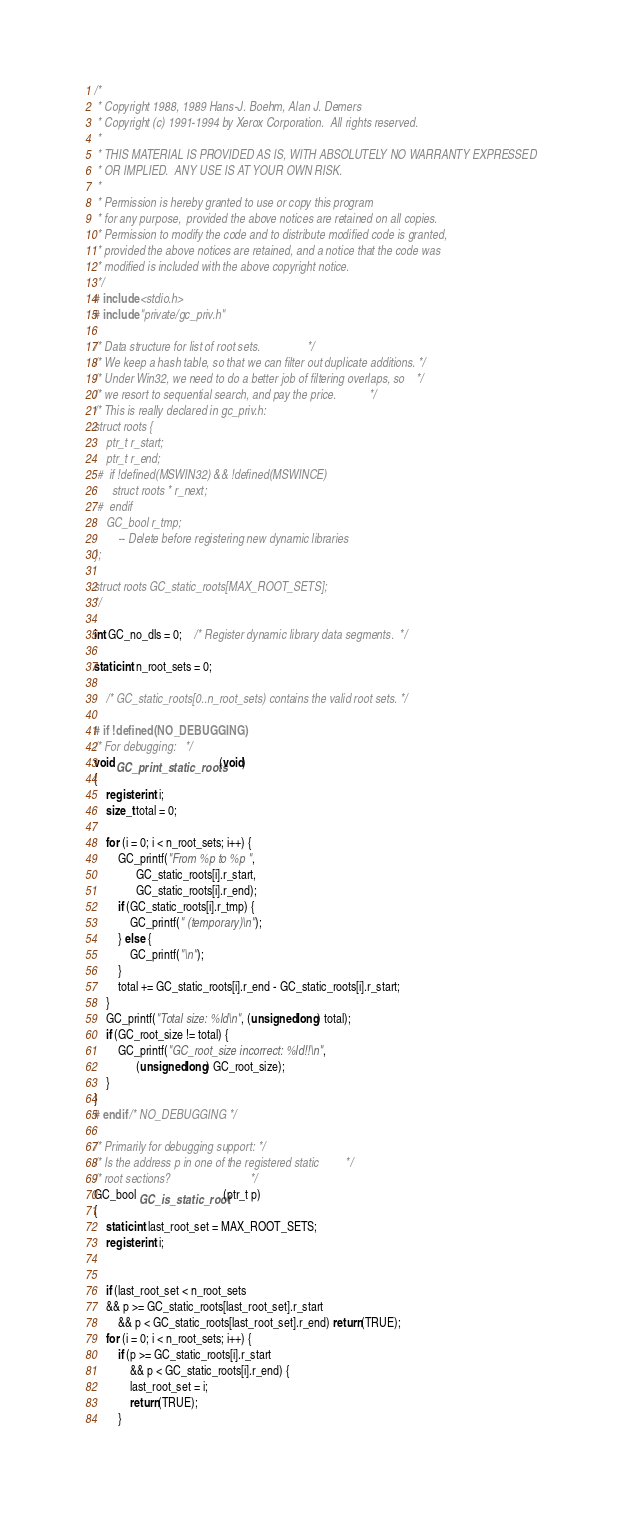<code> <loc_0><loc_0><loc_500><loc_500><_C_>/* 
 * Copyright 1988, 1989 Hans-J. Boehm, Alan J. Demers
 * Copyright (c) 1991-1994 by Xerox Corporation.  All rights reserved.
 *
 * THIS MATERIAL IS PROVIDED AS IS, WITH ABSOLUTELY NO WARRANTY EXPRESSED
 * OR IMPLIED.  ANY USE IS AT YOUR OWN RISK.
 *
 * Permission is hereby granted to use or copy this program
 * for any purpose,  provided the above notices are retained on all copies.
 * Permission to modify the code and to distribute modified code is granted,
 * provided the above notices are retained, and a notice that the code was
 * modified is included with the above copyright notice.
 */
# include <stdio.h>
# include "private/gc_priv.h"

/* Data structure for list of root sets.				*/
/* We keep a hash table, so that we can filter out duplicate additions.	*/
/* Under Win32, we need to do a better job of filtering overlaps, so	*/
/* we resort to sequential search, and pay the price.			*/
/* This is really declared in gc_priv.h:
struct roots {
	ptr_t r_start;
	ptr_t r_end;
 #	if !defined(MSWIN32) && !defined(MSWINCE)
	  struct roots * r_next;
 #	endif
	GC_bool r_tmp;
	  	-- Delete before registering new dynamic libraries
};

struct roots GC_static_roots[MAX_ROOT_SETS];
*/

int GC_no_dls = 0;	/* Register dynamic library data segments.	*/

static int n_root_sets = 0;

	/* GC_static_roots[0..n_root_sets) contains the valid root sets. */

# if !defined(NO_DEBUGGING)
/* For debugging:	*/
void GC_print_static_roots(void)
{
    register int i;
    size_t total = 0;
    
    for (i = 0; i < n_root_sets; i++) {
        GC_printf("From %p to %p ",
        	  GC_static_roots[i].r_start,
        	  GC_static_roots[i].r_end);
        if (GC_static_roots[i].r_tmp) {
            GC_printf(" (temporary)\n");
        } else {
            GC_printf("\n");
        }
        total += GC_static_roots[i].r_end - GC_static_roots[i].r_start;
    }
    GC_printf("Total size: %ld\n", (unsigned long) total);
    if (GC_root_size != total) {
     	GC_printf("GC_root_size incorrect: %ld!!\n",
     		  (unsigned long) GC_root_size);
    }
}
# endif /* NO_DEBUGGING */

/* Primarily for debugging support:	*/
/* Is the address p in one of the registered static			*/
/* root sections?							*/
GC_bool GC_is_static_root(ptr_t p)
{
    static int last_root_set = MAX_ROOT_SETS;
    register int i;
    
    
    if (last_root_set < n_root_sets
	&& p >= GC_static_roots[last_root_set].r_start
        && p < GC_static_roots[last_root_set].r_end) return(TRUE);
    for (i = 0; i < n_root_sets; i++) {
    	if (p >= GC_static_roots[i].r_start
            && p < GC_static_roots[i].r_end) {
            last_root_set = i;
            return(TRUE);
        }</code> 